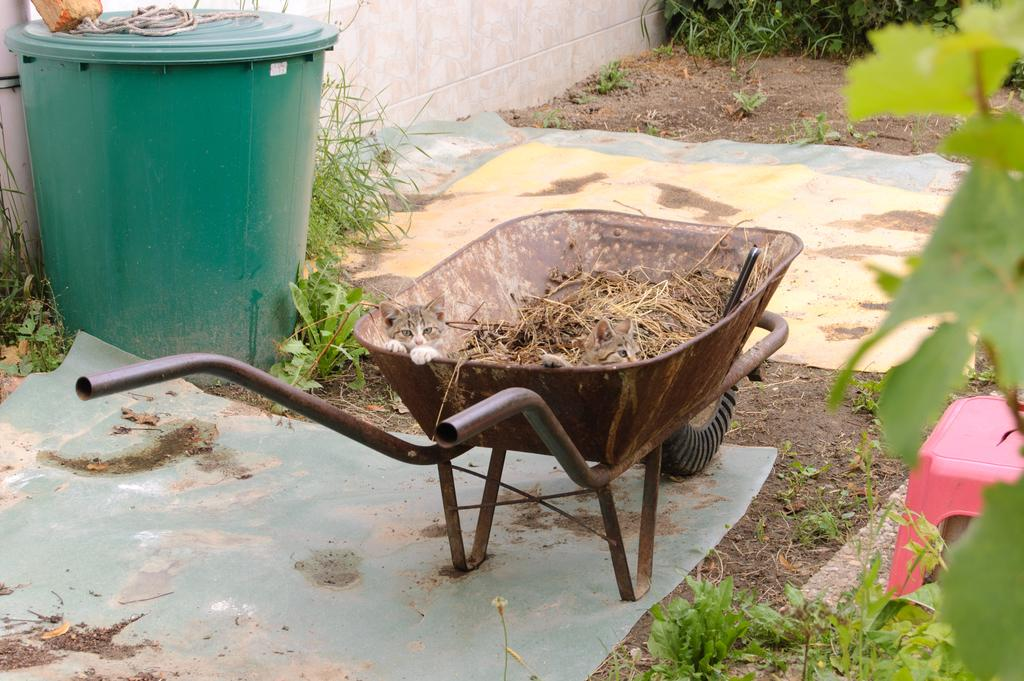What type of living organisms can be seen in the image? Plants and grass are visible in the image. What object is used for waste disposal in the image? A dustbin is present in the image. What type of flooring is present in the image? Mats are visible in the image. What type of seating is available in the image? A stool is visible in the image. What type of educational material is present in the image? There is a chart in the image. What type of waste material is present in the image? Waste material is present in the image. What is located on the left side of the image? There is a wall on the left side of the image. How many turkeys are visible in the image? There are no turkeys present in the image. What type of achievement is being celebrated in the image? There is no indication of any achievement being celebrated in the image. What type of building material is used for the wall on the left side of the image? The type of building material used for the wall is not visible in the image. 